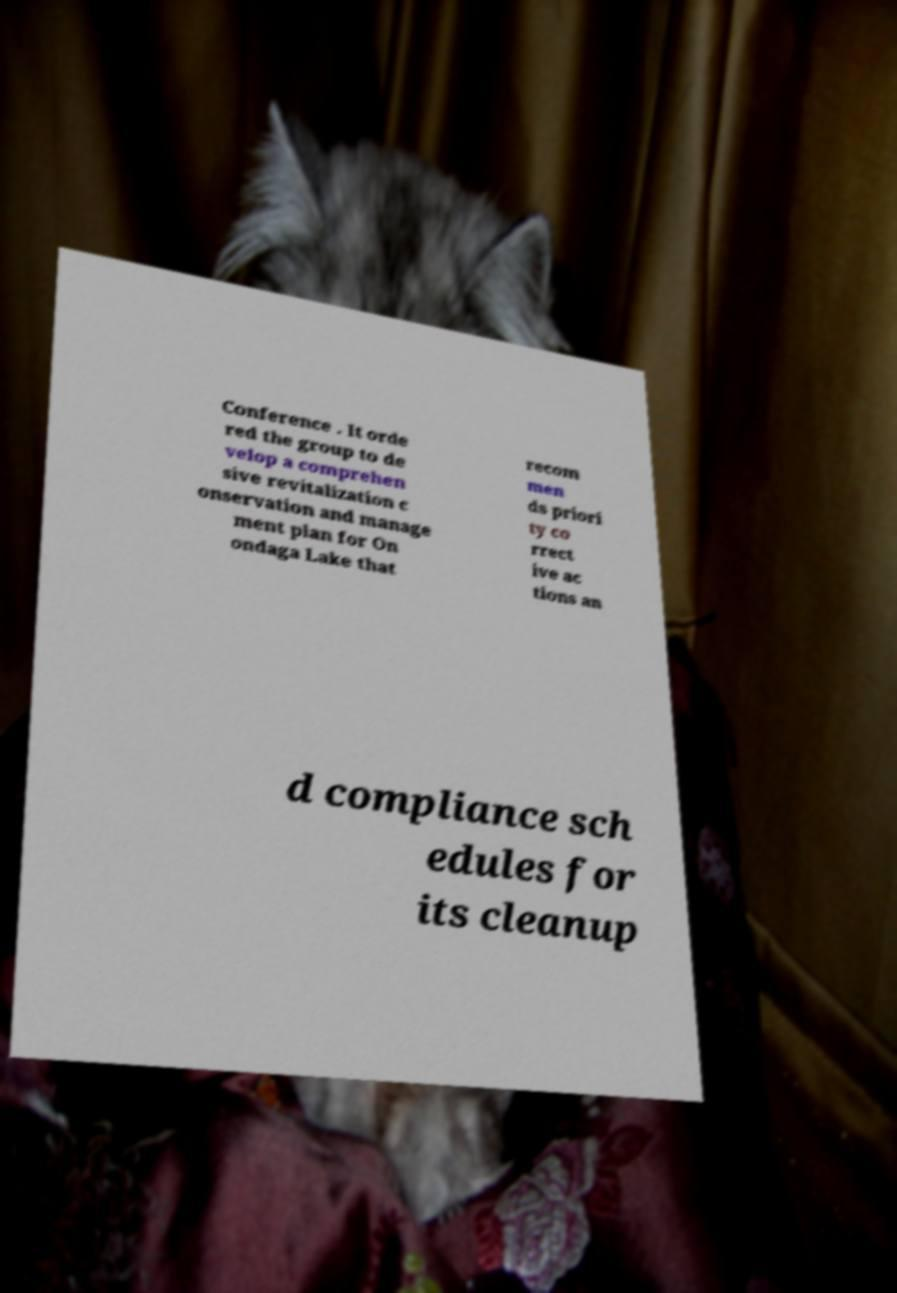For documentation purposes, I need the text within this image transcribed. Could you provide that? Conference . It orde red the group to de velop a comprehen sive revitalization c onservation and manage ment plan for On ondaga Lake that recom men ds priori ty co rrect ive ac tions an d compliance sch edules for its cleanup 